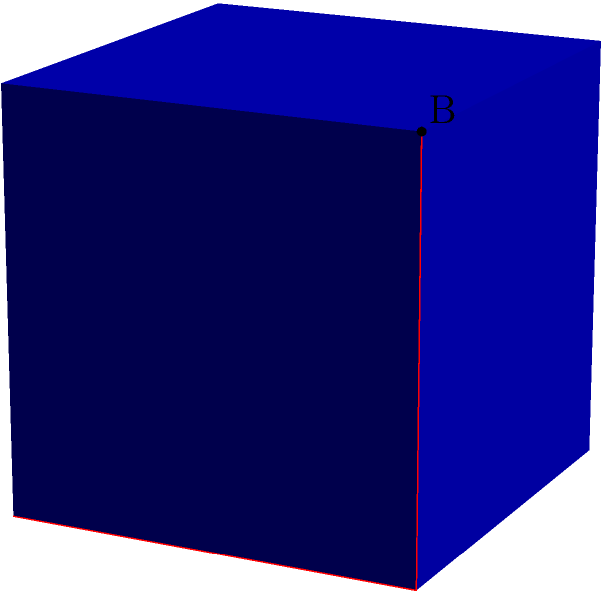As a wise octopus navigating the corners of a cubic aquarium, you need to find the shortest path between two opposite corners. Given a cube with side length 1, what is the shortest distance between points A(0,0,0) and B(1,1,1) along the surface of the cube? Let's approach this step-by-step:

1) The shortest path between two points on a surface is called a geodesic. On a cube, this path will consist of straight line segments on the cube's faces.

2) One way to visualize this path is to "unfold" the cube along the path. The shortest path will become a straight line in this unfolded view.

3) There are several possible paths, but the shortest one will use three faces of the cube, forming a right-angled triangle when unfolded.

4) This path consists of:
   - Moving from (0,0,0) to (1,0,0)
   - Then from (1,0,0) to (1,1,0)
   - Finally from (1,1,0) to (1,1,1)

5) Each of these segments has a length of 1, so the total path length is 3.

6) To prove this is the shortest path, we can use the Pythagorean theorem in 3D:

   $$\sqrt{1^2 + 1^2 + 1^2} = \sqrt{3}$$

7) Since $\sqrt{3} \approx 1.732 < 3$, this surface path is indeed longer than the direct path through the cube's interior.

8) However, among all possible surface paths, this one using three faces is the shortest.
Answer: $3$ 